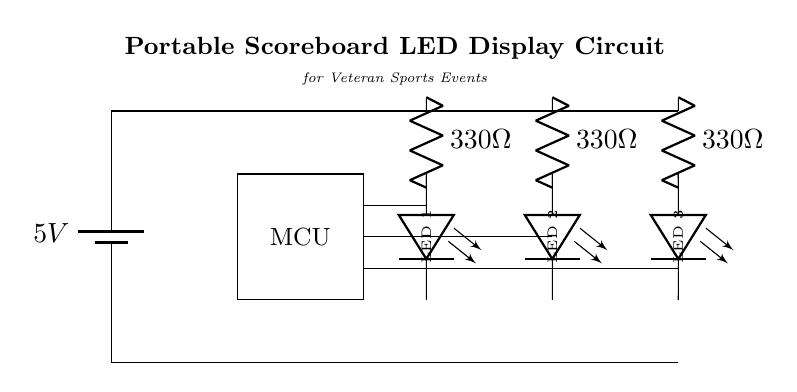What type of microcontroller is used in this circuit? The circuit diagram features a microcontroller (MCU), which is a central component that manages the operation of the LED display. There is no specific model indicated, but it is typically a programmable device designed for embedded applications.
Answer: MCU How many resistors are in this circuit? The circuit comprises three resistors, each labeled as 330 Ohms, which are used to limit the current flowing through the LEDs.
Answer: 3 What is the purpose of the resistors in this circuit? The resistors limit the current to protect the LEDs from drawing too much current, which could damage them. This is essential in ensuring the longevity and functionality of the LEDs.
Answer: Current limitation What is the power supply voltage in this circuit? The power supply voltage is provided as 5 volts, as indicated at the battery symbol in the circuit diagram. This voltage powers the entire circuit.
Answer: 5 volts Which components are LEDs in this circuit? The LEDs are located at the positions marked in the diagram, specifically between the nodes labeled for each LED. They are each connected to their respective current-limiting resistors and the microcontroller.
Answer: LED 1, LED 2, LED 3 How are the LEDs connected in this circuit? The LEDs are connected in parallel, each with its own series resistor. This configuration allows each LED to be driven independently while sharing the same voltage supply.
Answer: Parallel connection What is the function of the portable scoreboard LED display circuit? The circuit's function is to visually display scores for events, utilizing LED indicators controlled by a microcontroller, enabling quick and clear score updates during veteran sports events.
Answer: LED display for scores 